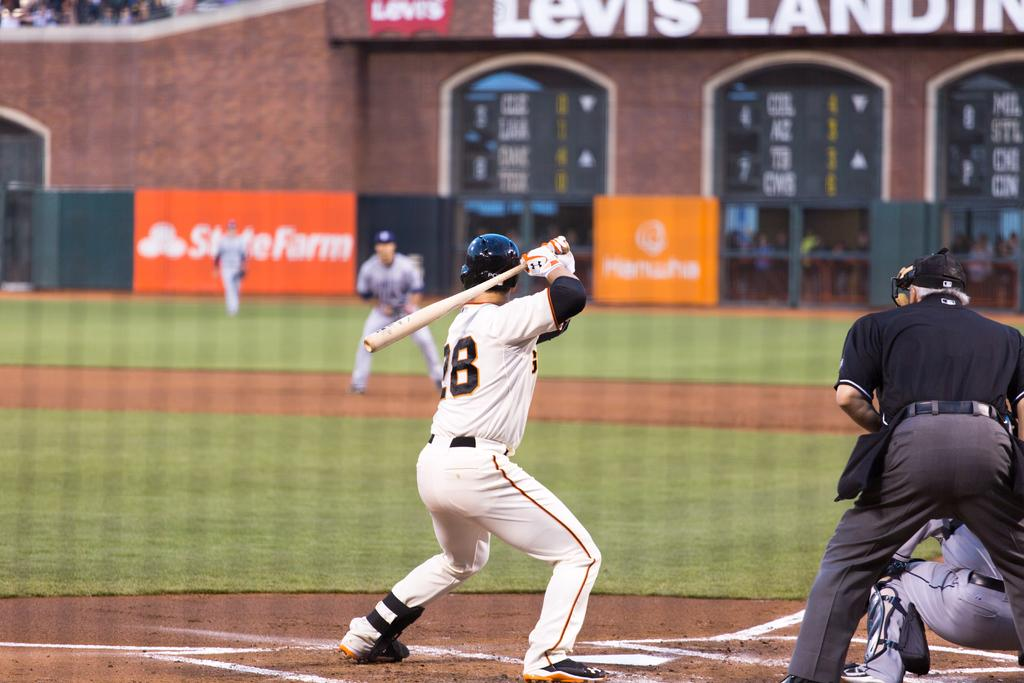<image>
Provide a brief description of the given image. a baseball player that's wearing the number 28 